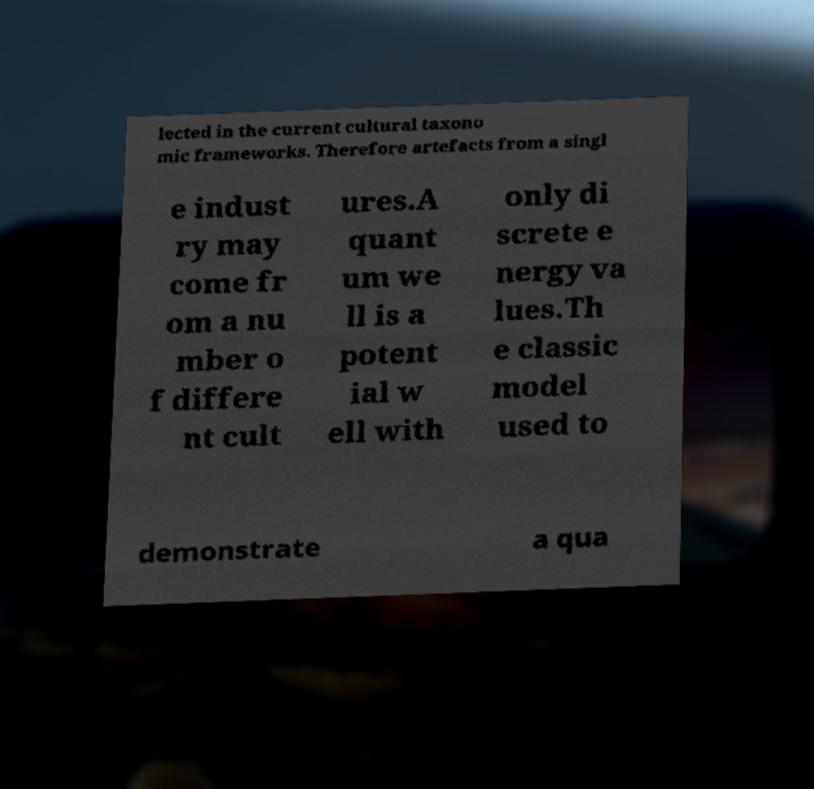What messages or text are displayed in this image? I need them in a readable, typed format. lected in the current cultural taxono mic frameworks. Therefore artefacts from a singl e indust ry may come fr om a nu mber o f differe nt cult ures.A quant um we ll is a potent ial w ell with only di screte e nergy va lues.Th e classic model used to demonstrate a qua 